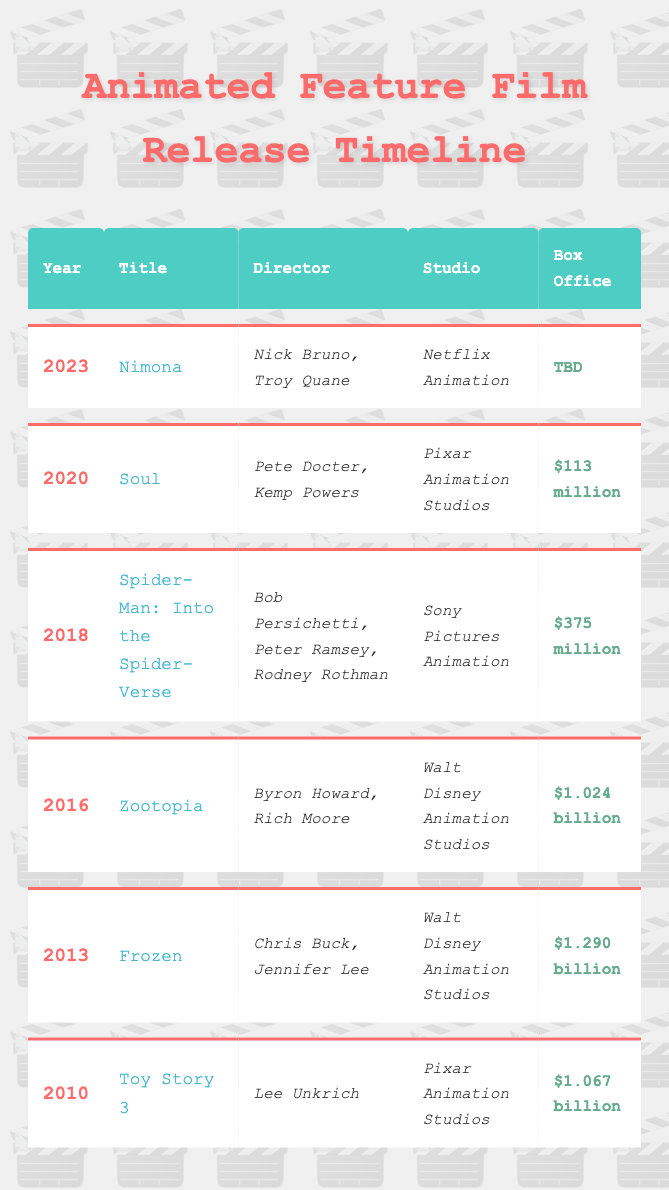What animated feature film was released in 2016? The table lists the films by year. Looking at the row for 2016, the title is "Zootopia."
Answer: Zootopia Which animated film has the highest box office earnings? By reviewing the "Box Office" column, the highest value is "$1.290 billion," which is linked to the film "Frozen" from 2013.
Answer: Frozen How many films released between 2010 and 2020 earned over $1 billion at the box office? Examining the table, the films are "Toy Story 3" ($1.067 billion), "Frozen" ($1.290 billion), and "Zootopia" ($1.024 billion). That gives us three films, counting the amounts.
Answer: 3 Is "Soul" directed by a single person? Looking at the director of "Soul," it lists "Pete Docter, Kemp Powers," indicating that it has multiple directors.
Answer: No What is the average box office earnings of the animated features listed from 2010 to 2020? The box office earnings are $1.067 billion (Toy Story 3), $1.290 billion (Frozen), $1.024 billion (Zootopia), $375 million (Spider-Man: Into the Spider-Verse), and $113 million (Soul). First, we convert these amounts to millions: 1067, 1290, 1024, 375, 113. Then, add them: 1067 + 1290 + 1024 + 375 + 113 = 3869 million. Finally, divide by the number of films (5): 3869 / 5 = 773.8.
Answer: 773.8 million Which studio released the film "Spider-Man: Into the Spider-Verse"? Reviewing the row for "Spider-Man: Into the Spider-Verse," the studio listed is "Sony Pictures Animation."
Answer: Sony Pictures Animation 